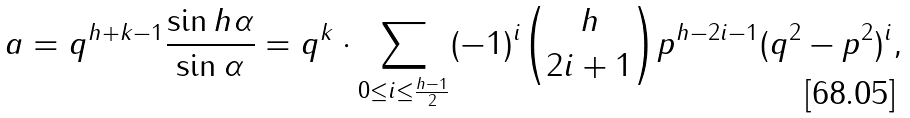<formula> <loc_0><loc_0><loc_500><loc_500>a = q ^ { h + k - 1 } { \frac { \sin h \alpha } { \sin \alpha } } = q ^ { k } \cdot \sum _ { 0 \leq i \leq { \frac { h - 1 } { 2 } } } ( - 1 ) ^ { i } { \binom { h } { 2 i + 1 } } p ^ { h - 2 i - 1 } ( q ^ { 2 } - p ^ { 2 } ) ^ { i } ,</formula> 